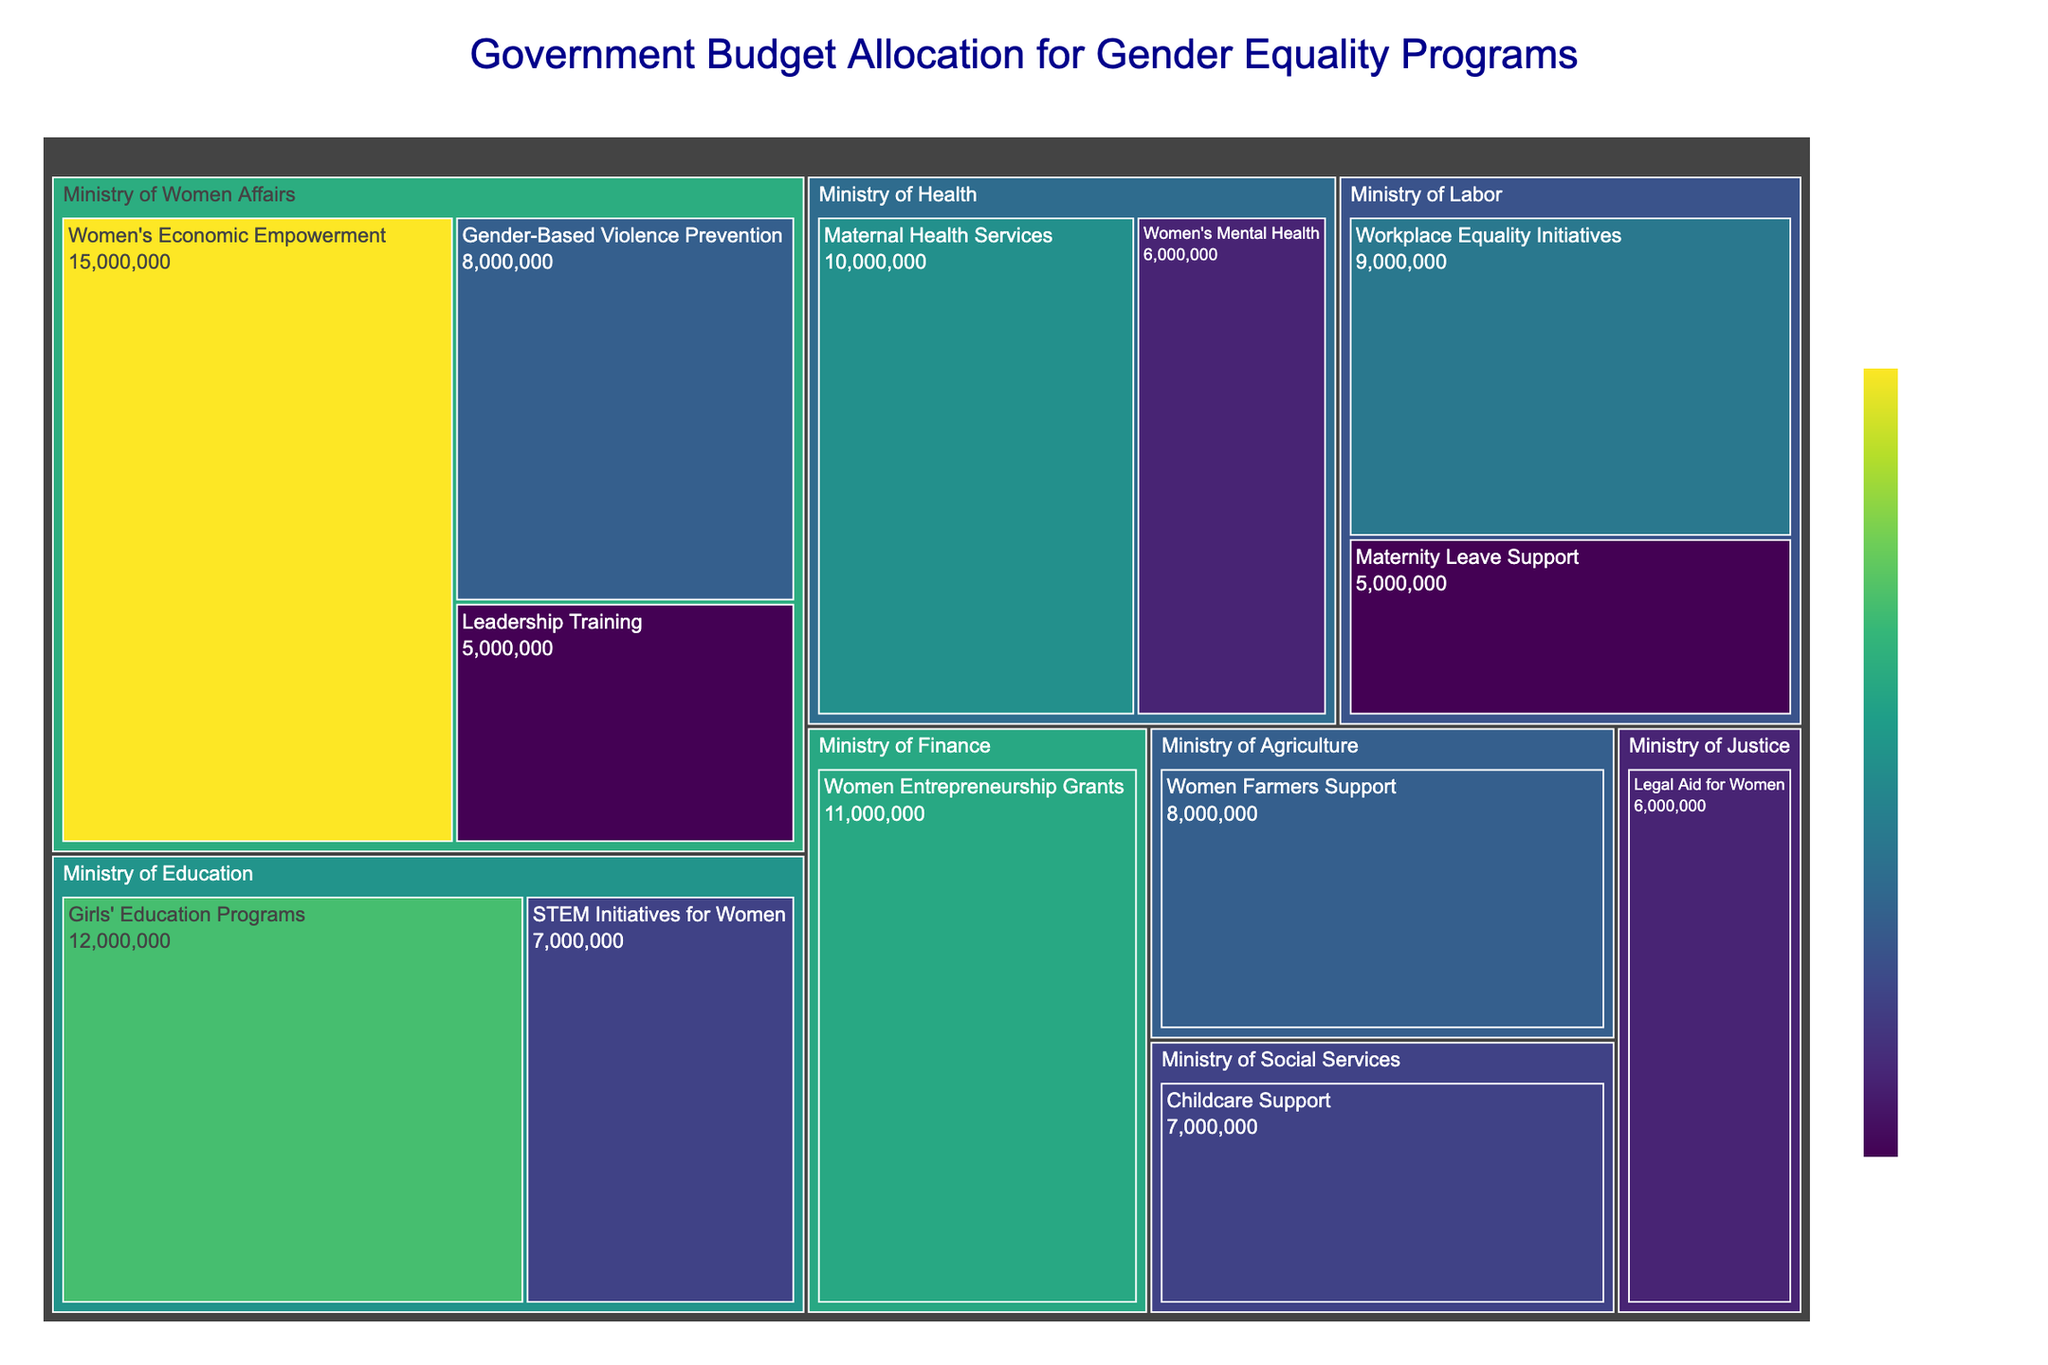What is the total budget allocation for the Ministry of Women Affairs? Sum the budget allocation for each category under the Ministry of Women Affairs: $15,000,000 + $8,000,000 + $5,000,000 = $28,000,000
Answer: $28,000,000 Which department has the highest budget allocation and what is it for? Compare the highest budget allocation across all departments. The highest is the Ministry of Women Affairs with $15,000,000 for Women's Economic Empowerment.
Answer: Ministry of Women Affairs for Women's Economic Empowerment What is the budget difference between Girls' Education Programs and STEM Initiatives for Women under the Ministry of Education? Subtract the budget for STEM Initiatives for Women from Girls' Education Programs: $12,000,000 - $7,000,000 = $5,000,000
Answer: $5,000,000 Which category under the Ministry of Health receives the higher budget, and by how much? Compare the budget for Maternal Health Services and Women's Mental Health and find the difference: $10,000,000 - $6,000,000 = $4,000,000
Answer: Maternal Health Services by $4,000,000 How many categories are supported by the Ministry of Social Services and the Ministry of Finance combined? Count the categories under both ministries: Ministry of Social Services (1) + Ministry of Finance (1) = 2
Answer: 2 What is the proportion of the budget allocated for Workplace Equality Initiatives and Maternity Leave Support under the Ministry of Labor? Calculate the total budget and find the proportion of each category: Total budget is $9,000,000 + $5,000,000 = $14,000,000. Workplace Equality Initiatives is $9,000,000 / $14,000,000 = 64.3%, Maternity Leave Support is $5,000,000 / $14,000,000 = 35.7%
Answer: Workplace Equality Initiatives: 64.3%, Maternity Leave Support: 35.7% Which department received the lowest single budget allocation, and what category is it for? Identify the lowest budget allocation from all categories: Leadership Training under the Ministry of Women Affairs with $5,000,000
Answer: Ministry of Women Affairs for Leadership Training What is the average budget allocation across all categories listed in the figure? Sum all budget allocations and divide by the number of categories: ($15,000,000 + $8,000,000 + $5,000,000 + $12,000,000 + $7,000,000 + $10,000,000 + $6,000,000 + $9,000,000 + $5,000,000 + $6,000,000 + $8,000,000 + $7,000,000 + $11,000,000) / 13 = $8,615,385
Answer: $8,615,385 How does the budget allocation of Legal Aid for Women compare to the average budget allocation? Calculate the difference between the budget for Legal Aid for Women and the average budget allocation: $6,000,000 - $8,615,385 = -$2,615,385
Answer: $2,615,385 below average 